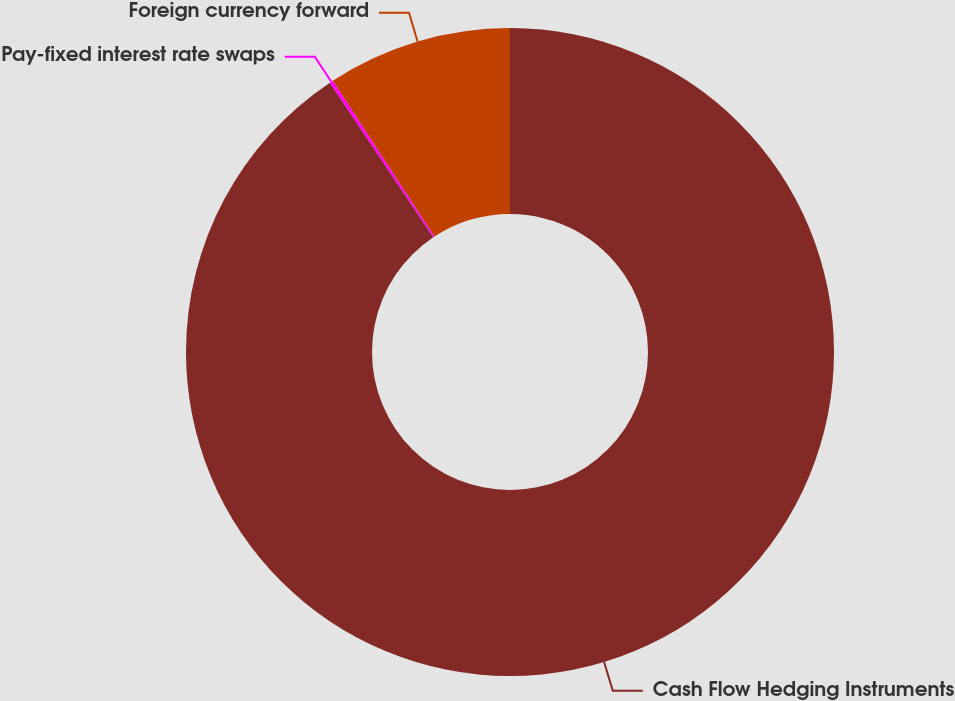Convert chart. <chart><loc_0><loc_0><loc_500><loc_500><pie_chart><fcel>Cash Flow Hedging Instruments<fcel>Pay-fixed interest rate swaps<fcel>Foreign currency forward<nl><fcel>90.62%<fcel>0.17%<fcel>9.21%<nl></chart> 